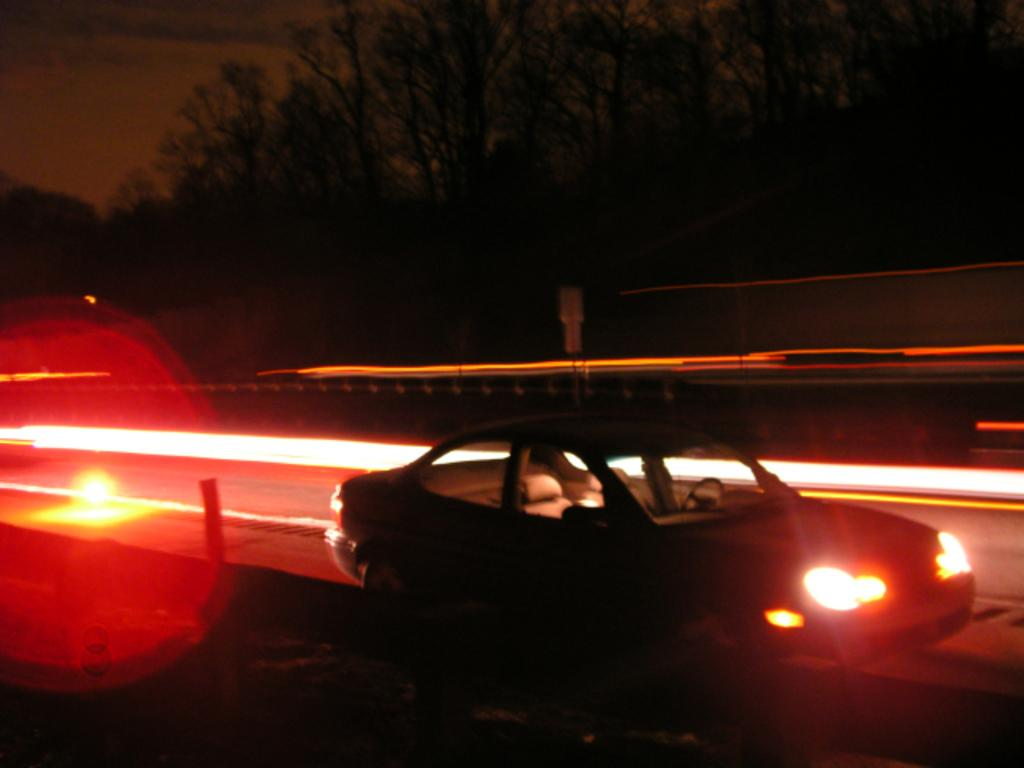What is the main subject of the image? There is a car in the image. Where is the car located? The car is on the road. What can be seen in the background of the image? There is a tree, fencing, and the sky visible in the background of the image. How does the car feel about the shock it experienced in the image? Cars do not have feelings, so it is not possible to determine how the car feels about any shock in the image. 